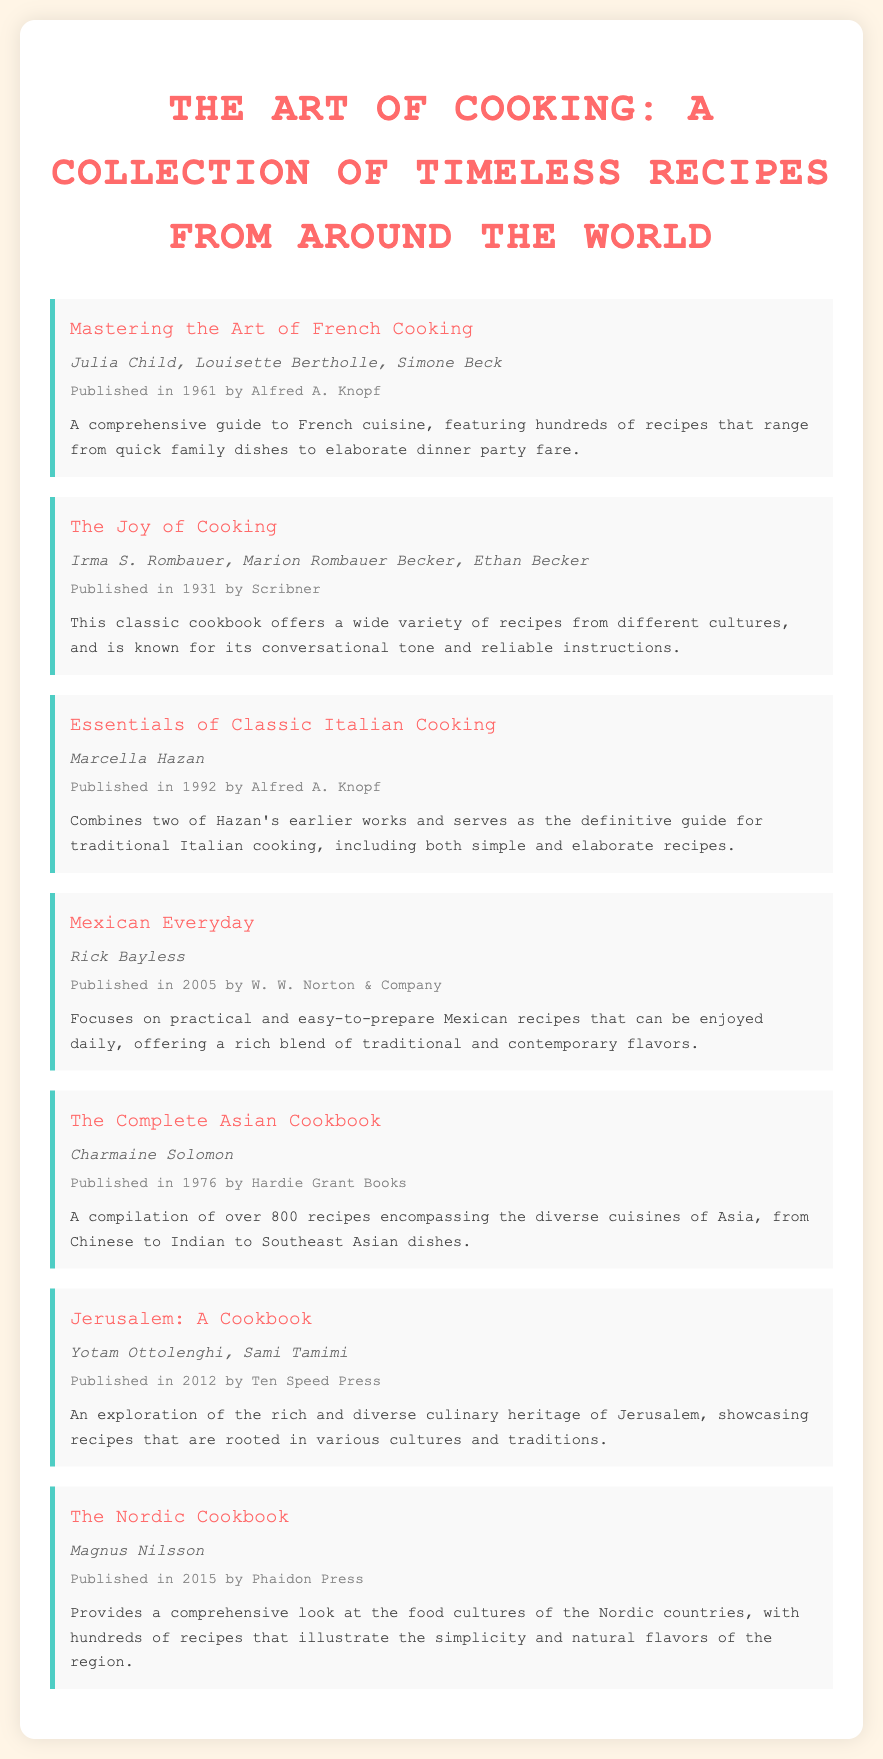what is the title of the document? The title of the document is specified in the header of the rendered HTML.
Answer: The Art of Cooking: A Collection of Timeless Recipes from Around the World who is the author of "Mastering the Art of French Cooking"? The document lists the authors of this book in the bibliography section.
Answer: Julia Child, Louisette Bertholle, Simone Beck when was "The Joy of Cooking" published? The publication date is provided in the book information section for this title.
Answer: 1931 how many recipes does "The Complete Asian Cookbook" feature? The document mentions the number of recipes featured in this book.
Answer: Over 800 recipes what is the main focus of "Mexican Everyday"? The document describes the content of this cookbook, highlighting its aim.
Answer: Practical and easy-to-prepare Mexican recipes which book is authored by Marcella Hazan? The bibliography lists the authors for each title, and this question focuses on identifying the specific book she wrote.
Answer: Essentials of Classic Italian Cooking what is unique about "Jerusalem: A Cookbook"? The document's description outlines the distinctive aspects of this cookbook.
Answer: Culinary heritage of Jerusalem who published "The Nordic Cookbook"? The document includes the publisher's name in the book information.
Answer: Phaidon Press 